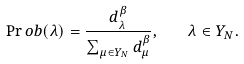Convert formula to latex. <formula><loc_0><loc_0><loc_500><loc_500>\Pr o b ( \lambda ) = \frac { d _ { \lambda } ^ { \beta } } { \sum _ { \mu \in Y _ { N } } d _ { \mu } ^ { \beta } } , \quad \lambda \in Y _ { N } .</formula> 